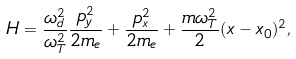<formula> <loc_0><loc_0><loc_500><loc_500>H = \frac { \omega _ { d } ^ { 2 } } { \omega _ { T } ^ { 2 } } \frac { p _ { y } ^ { 2 } } { 2 m _ { e } } + \frac { p _ { x } ^ { 2 } } { 2 m _ { e } } + \frac { m \omega _ { T } ^ { 2 } } { 2 } ( x - x _ { 0 } ) ^ { 2 } ,</formula> 